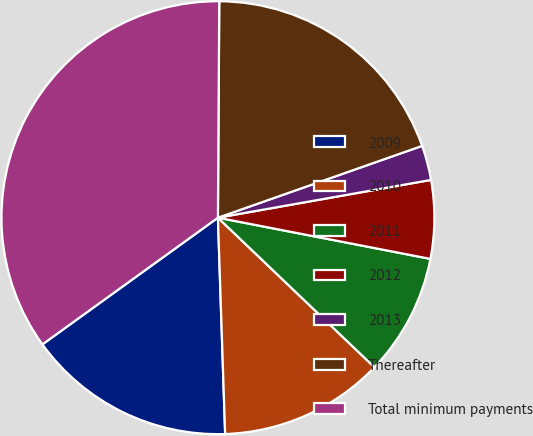Convert chart to OTSL. <chart><loc_0><loc_0><loc_500><loc_500><pie_chart><fcel>2009<fcel>2010<fcel>2011<fcel>2012<fcel>2013<fcel>Thereafter<fcel>Total minimum payments<nl><fcel>15.58%<fcel>12.33%<fcel>9.09%<fcel>5.84%<fcel>2.59%<fcel>19.52%<fcel>35.05%<nl></chart> 